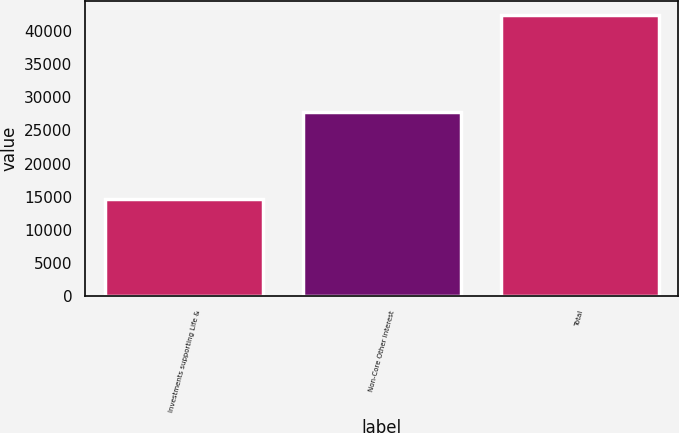Convert chart. <chart><loc_0><loc_0><loc_500><loc_500><bar_chart><fcel>Investments supporting Life &<fcel>Non-Core Other interest<fcel>Total<nl><fcel>14668<fcel>27748<fcel>42416<nl></chart> 